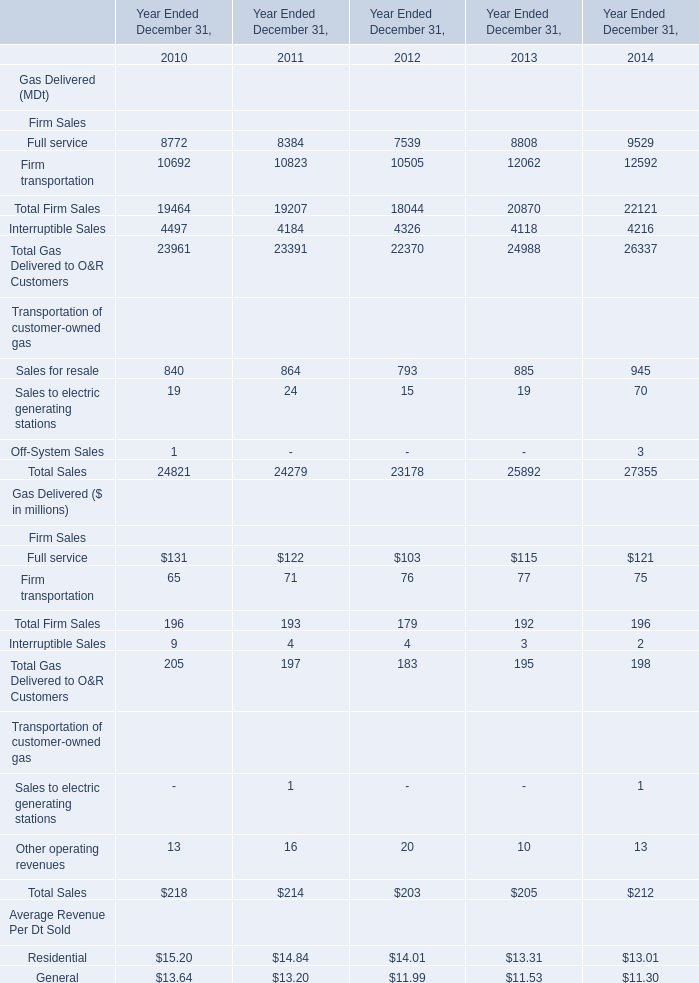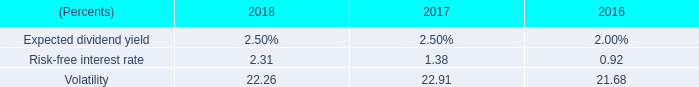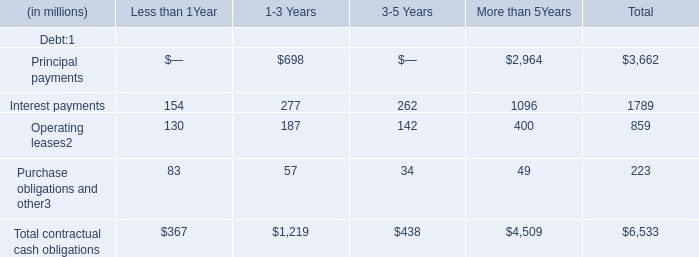what was the percentage change in dollars spent on share repurchase between 2017 and 2018? 
Computations: (((4.15 * 1000) - 359.8) / 359.8)
Answer: 10.53419. 